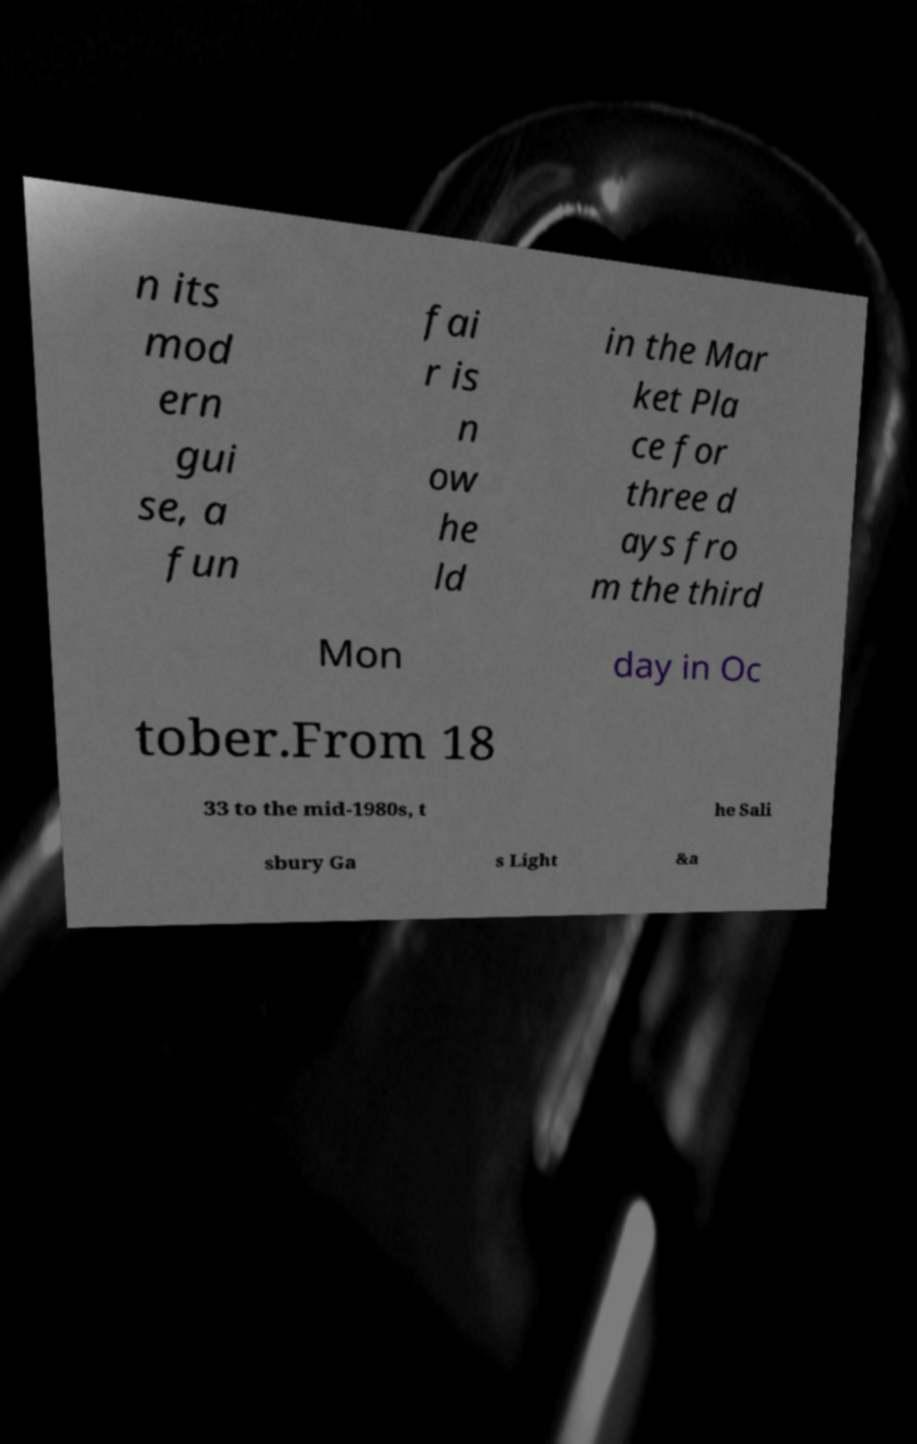Can you read and provide the text displayed in the image?This photo seems to have some interesting text. Can you extract and type it out for me? n its mod ern gui se, a fun fai r is n ow he ld in the Mar ket Pla ce for three d ays fro m the third Mon day in Oc tober.From 18 33 to the mid-1980s, t he Sali sbury Ga s Light &a 